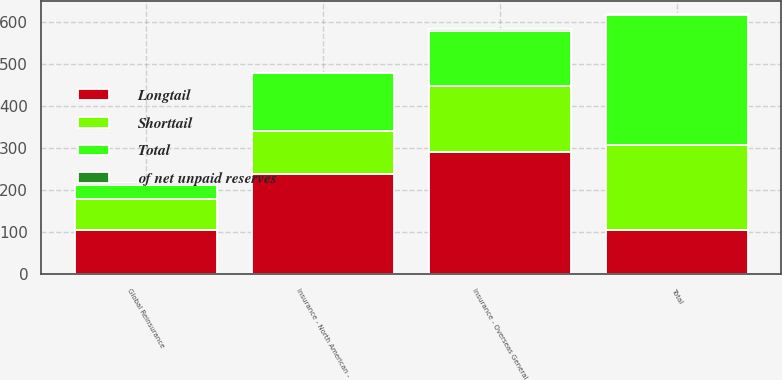Convert chart. <chart><loc_0><loc_0><loc_500><loc_500><stacked_bar_chart><ecel><fcel>Insurance - North American -<fcel>Insurance - Overseas General<fcel>Global Reinsurance<fcel>Total<nl><fcel>Shorttail<fcel>102<fcel>159<fcel>72<fcel>201<nl><fcel>Total<fcel>137<fcel>131<fcel>34<fcel>311<nl><fcel>Longtail<fcel>239<fcel>290<fcel>106<fcel>106<nl><fcel>of net unpaid reserves<fcel>1.5<fcel>4.3<fcel>4.7<fcel>2<nl></chart> 